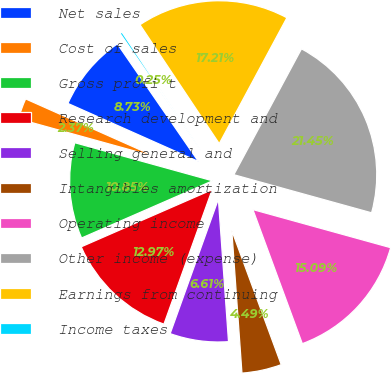<chart> <loc_0><loc_0><loc_500><loc_500><pie_chart><fcel>Net sales<fcel>Cost of sales<fcel>Gross profi t<fcel>Research development and<fcel>Selling general and<fcel>Intangibles amortization<fcel>Operating income<fcel>Other income (expense)<fcel>Earnings from continuing<fcel>Income taxes<nl><fcel>8.73%<fcel>2.37%<fcel>10.85%<fcel>12.97%<fcel>6.61%<fcel>4.49%<fcel>15.09%<fcel>21.45%<fcel>17.21%<fcel>0.25%<nl></chart> 